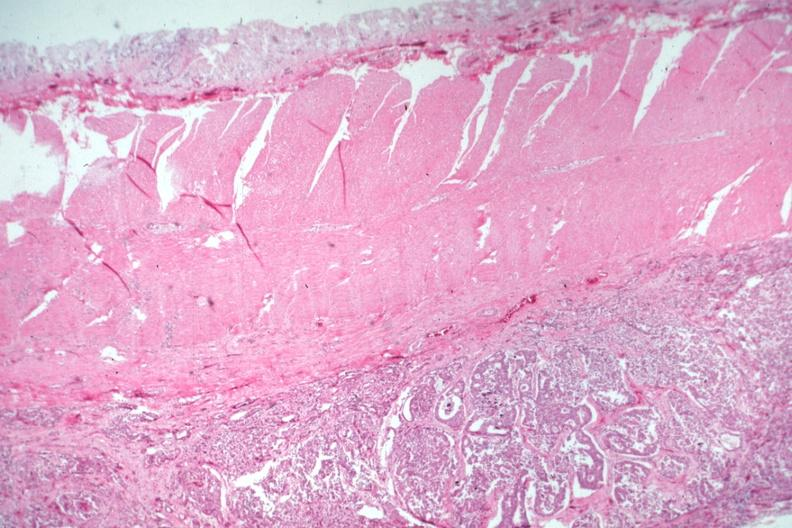s no tissue recognizable as ovary present?
Answer the question using a single word or phrase. No 